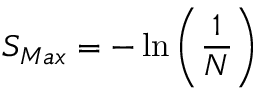<formula> <loc_0><loc_0><loc_500><loc_500>S _ { M a x } = - \ln \left ( \frac { 1 } { N } \right )</formula> 